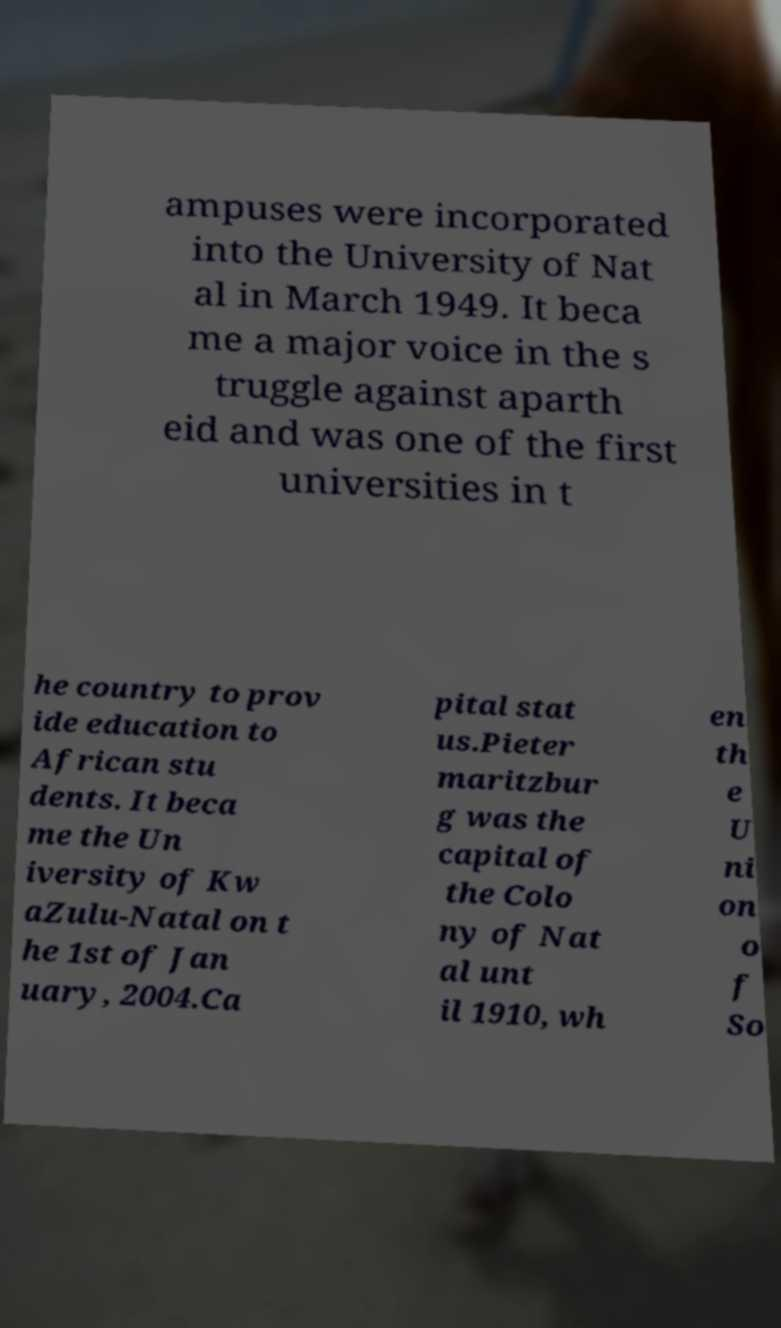Could you assist in decoding the text presented in this image and type it out clearly? ampuses were incorporated into the University of Nat al in March 1949. It beca me a major voice in the s truggle against aparth eid and was one of the first universities in t he country to prov ide education to African stu dents. It beca me the Un iversity of Kw aZulu-Natal on t he 1st of Jan uary, 2004.Ca pital stat us.Pieter maritzbur g was the capital of the Colo ny of Nat al unt il 1910, wh en th e U ni on o f So 